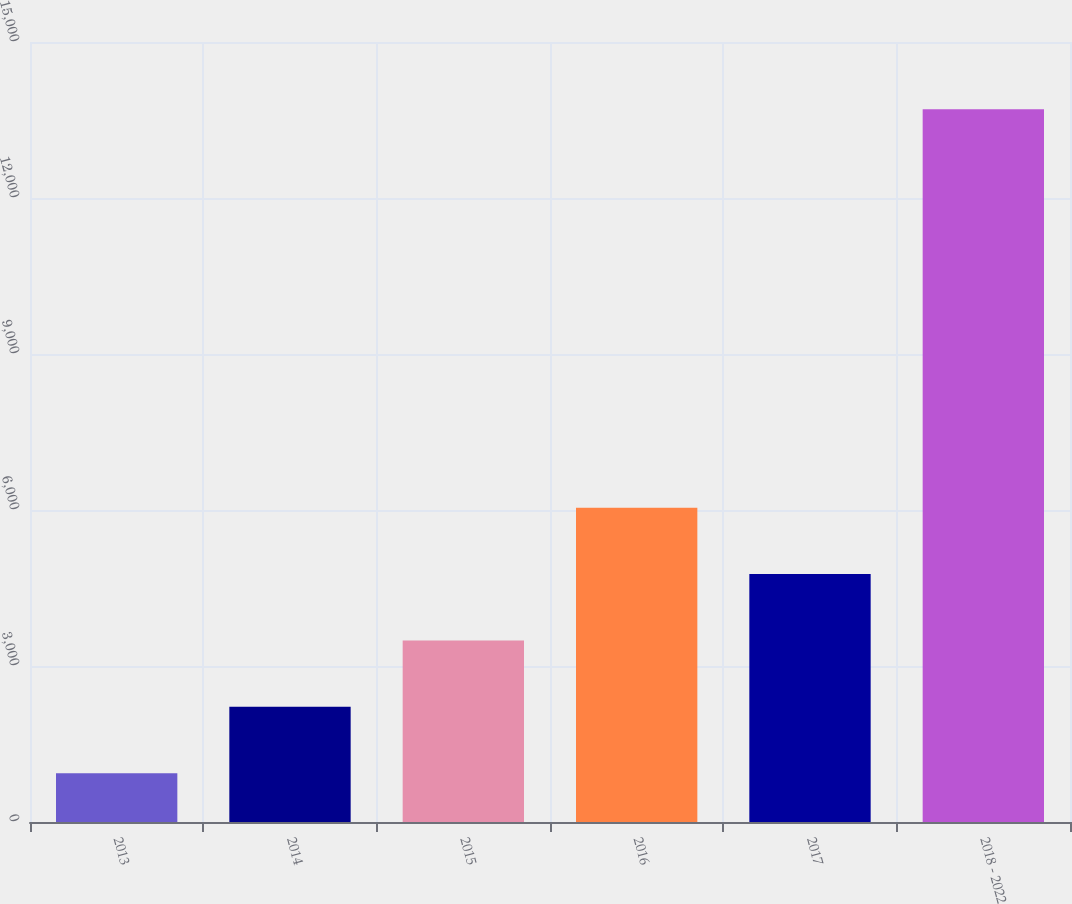<chart> <loc_0><loc_0><loc_500><loc_500><bar_chart><fcel>2013<fcel>2014<fcel>2015<fcel>2016<fcel>2017<fcel>2018 - 2022<nl><fcel>939<fcel>2215.6<fcel>3492.2<fcel>6045.4<fcel>4768.8<fcel>13705<nl></chart> 